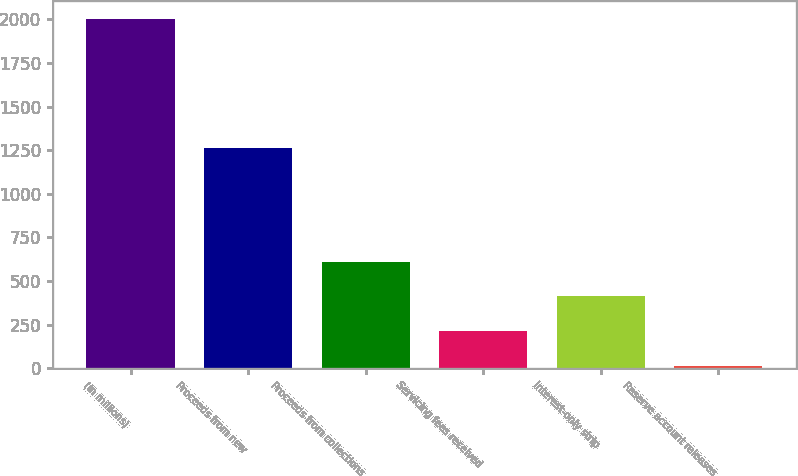Convert chart to OTSL. <chart><loc_0><loc_0><loc_500><loc_500><bar_chart><fcel>(In millions)<fcel>Proceeds from new<fcel>Proceeds from collections<fcel>Servicing fees received<fcel>Interest-only strip<fcel>Reserve account releases<nl><fcel>2005<fcel>1260<fcel>611.37<fcel>213.19<fcel>412.28<fcel>14.1<nl></chart> 